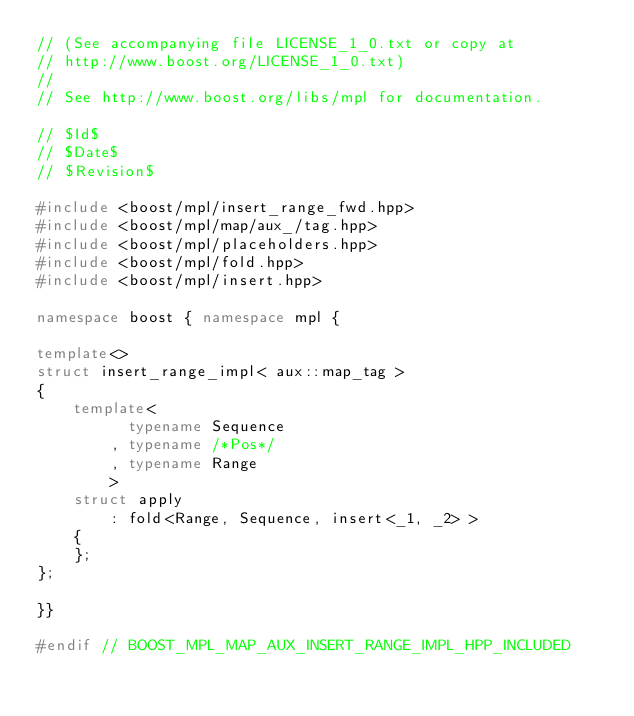Convert code to text. <code><loc_0><loc_0><loc_500><loc_500><_C++_>// (See accompanying file LICENSE_1_0.txt or copy at
// http://www.boost.org/LICENSE_1_0.txt)
//
// See http://www.boost.org/libs/mpl for documentation.

// $Id$
// $Date$
// $Revision$

#include <boost/mpl/insert_range_fwd.hpp>
#include <boost/mpl/map/aux_/tag.hpp>
#include <boost/mpl/placeholders.hpp>
#include <boost/mpl/fold.hpp>
#include <boost/mpl/insert.hpp>

namespace boost { namespace mpl {

template<>
struct insert_range_impl< aux::map_tag >
{
    template<
          typename Sequence
        , typename /*Pos*/
        , typename Range
        >
    struct apply
        : fold<Range, Sequence, insert<_1, _2> >
    {
    };
};

}}

#endif // BOOST_MPL_MAP_AUX_INSERT_RANGE_IMPL_HPP_INCLUDED
</code> 